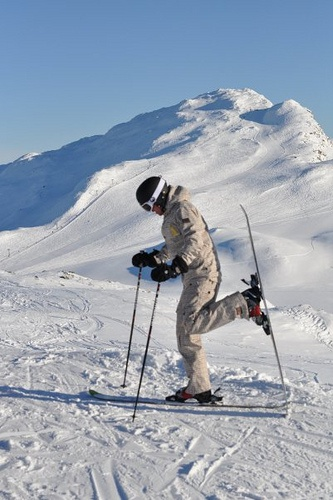Describe the objects in this image and their specific colors. I can see people in gray, black, darkgray, and lightgray tones and skis in gray, darkgray, and lightgray tones in this image. 